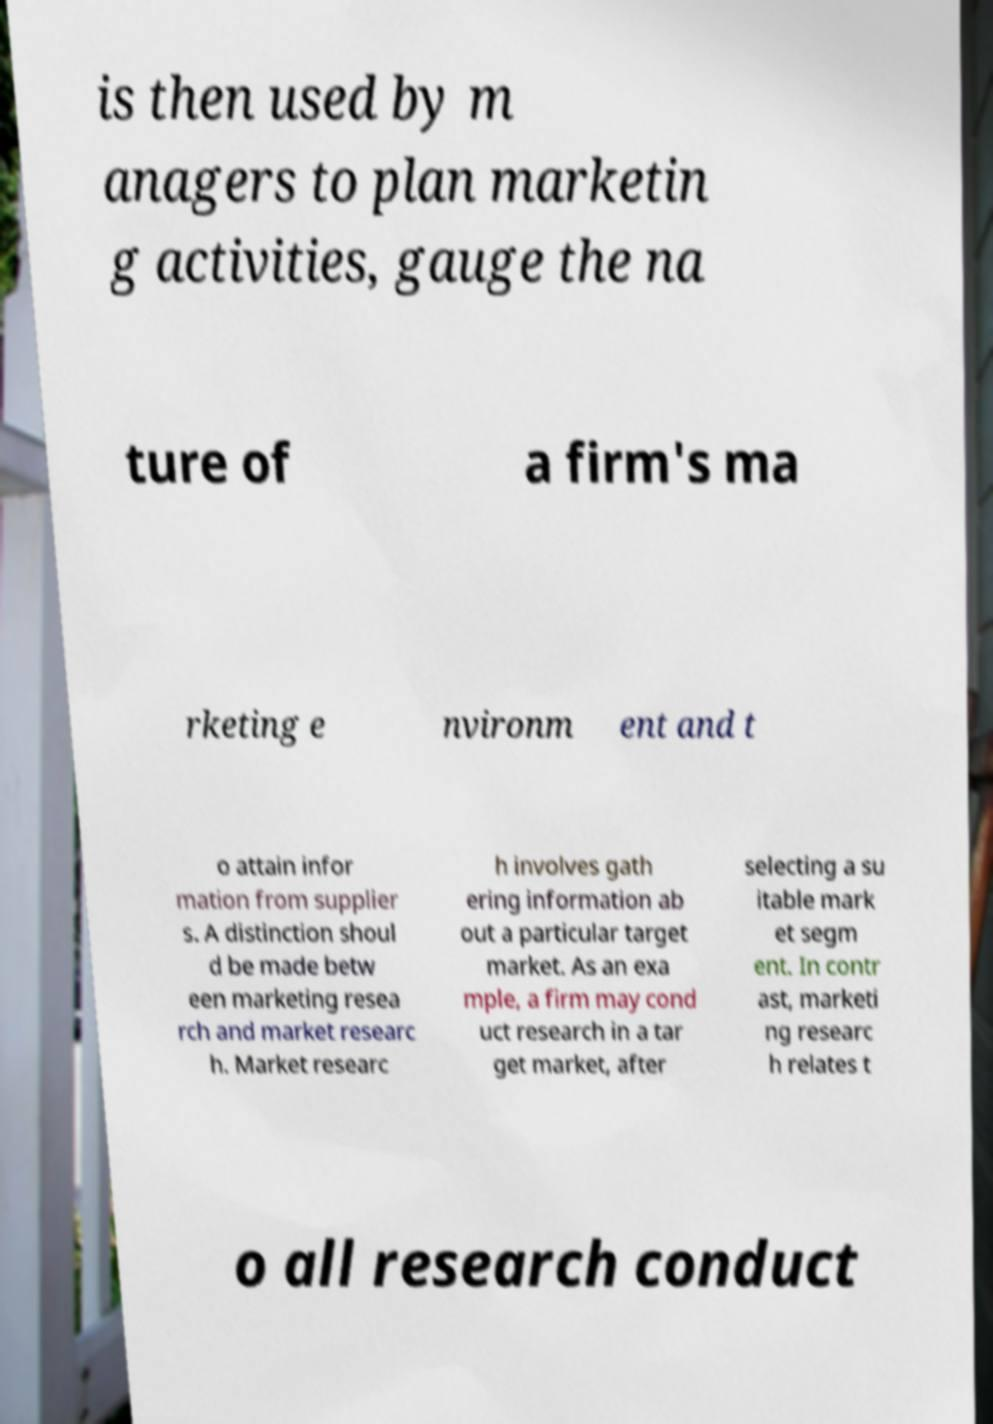I need the written content from this picture converted into text. Can you do that? is then used by m anagers to plan marketin g activities, gauge the na ture of a firm's ma rketing e nvironm ent and t o attain infor mation from supplier s. A distinction shoul d be made betw een marketing resea rch and market researc h. Market researc h involves gath ering information ab out a particular target market. As an exa mple, a firm may cond uct research in a tar get market, after selecting a su itable mark et segm ent. In contr ast, marketi ng researc h relates t o all research conduct 